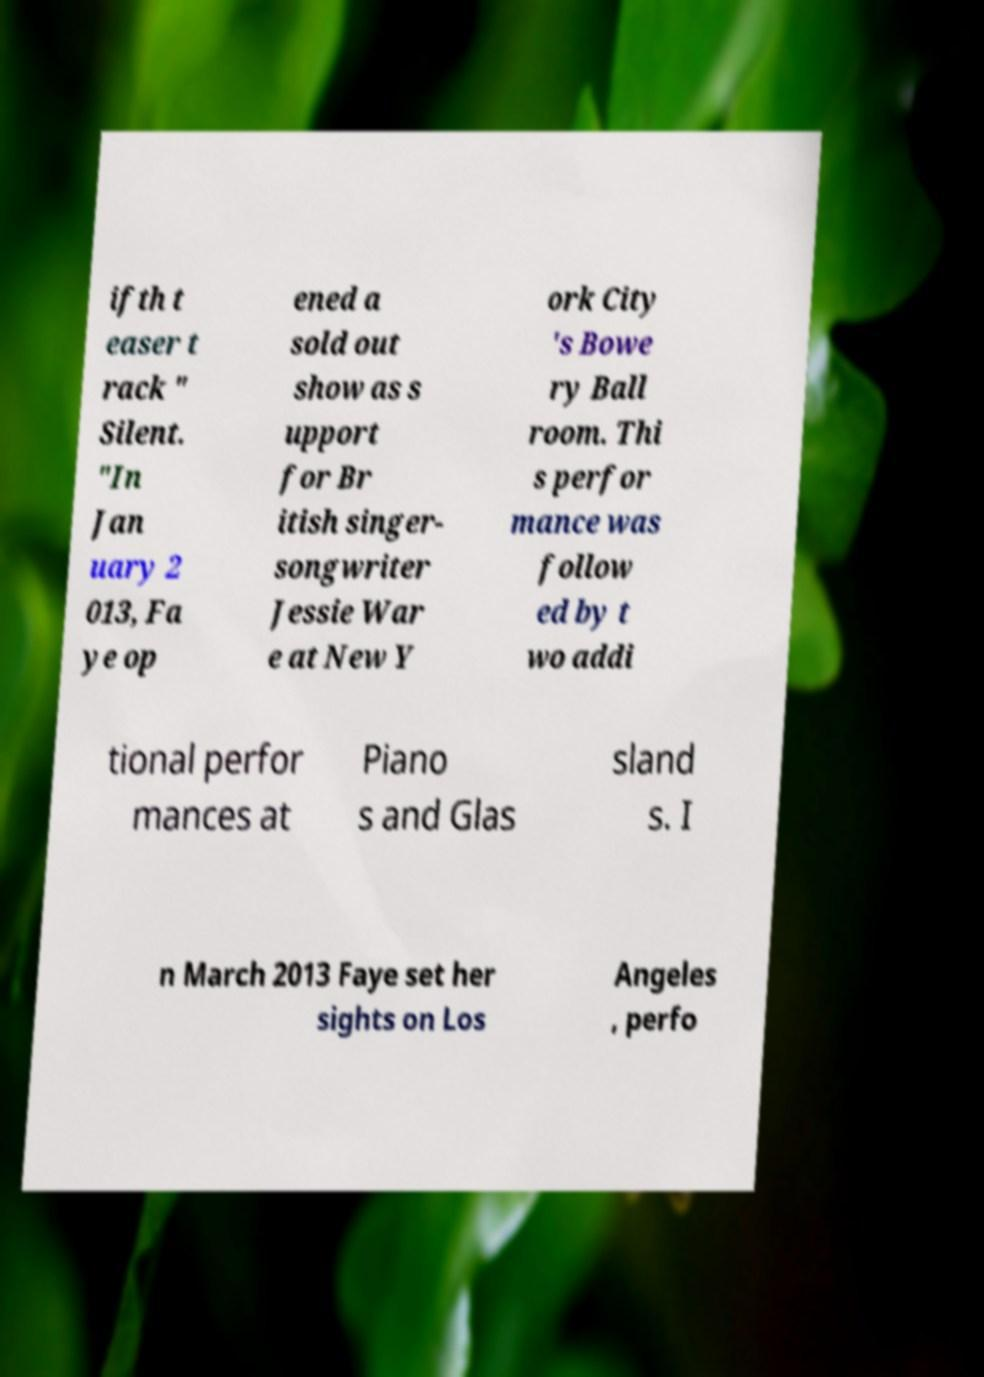Could you extract and type out the text from this image? ifth t easer t rack " Silent. "In Jan uary 2 013, Fa ye op ened a sold out show as s upport for Br itish singer- songwriter Jessie War e at New Y ork City 's Bowe ry Ball room. Thi s perfor mance was follow ed by t wo addi tional perfor mances at Piano s and Glas sland s. I n March 2013 Faye set her sights on Los Angeles , perfo 